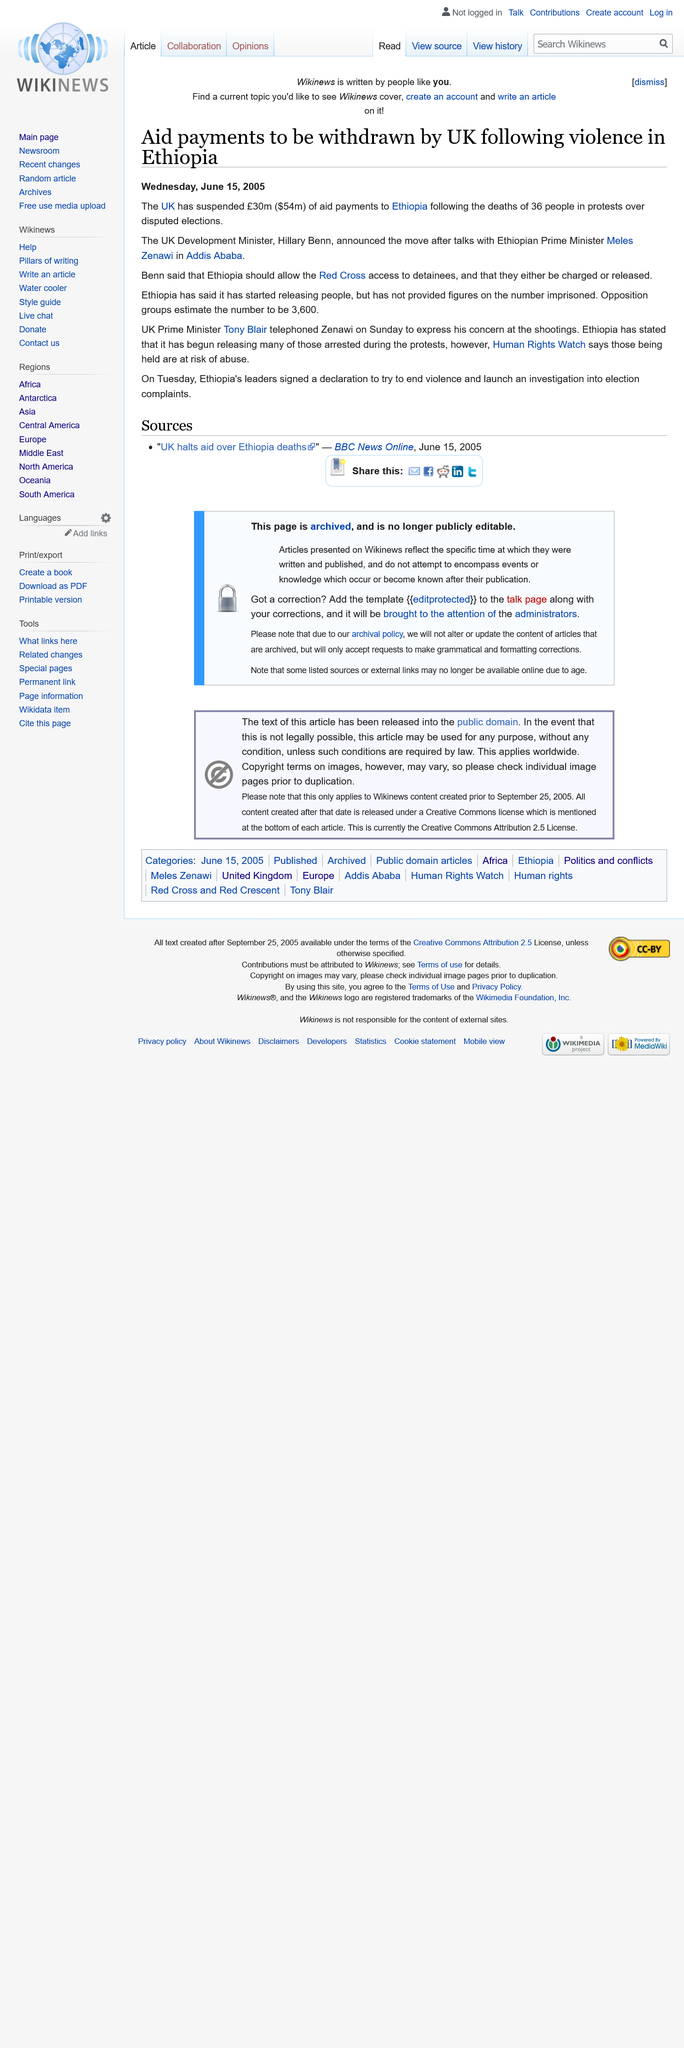Specify some key components in this picture. The United Kingdom has decided to withdraw aid payments due to the ongoing violence in Ethiopia over disputed elections. The article was published on Wednesday, June 15, 2005. It is imperative that the Red Cross be granted access to detainees and that they either be charged or released promptly, as stated by Hillary Benn. 